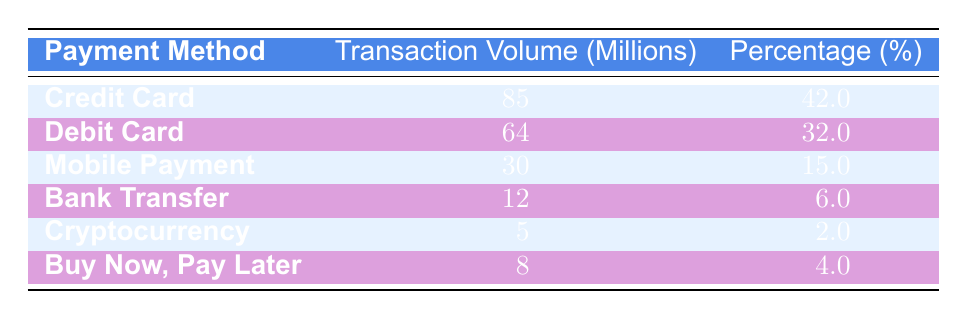What is the transaction volume for Credit Card payments? The table shows that the transaction volume for Credit Card payments is listed as 85 million.
Answer: 85 million What percentage of the total transaction volume comes from Debit Card payments? According to the table, the percentage of the total transaction volume for Debit Card payments is 32%.
Answer: 32% Which payment method has the lowest transaction volume, and what is that volume? The payment method with the lowest transaction volume listed in the table is Cryptocurrency, with a volume of 5 million.
Answer: Cryptocurrency, 5 million What is the total transaction volume for Mobile Payment and Buy Now, Pay Later combined? From the table, Mobile Payment has a volume of 30 million and Buy Now, Pay Later has a volume of 8 million. The total is 30 + 8 = 38 million.
Answer: 38 million Is the transaction volume from Bank Transfer greater than that from Cryptocurrency? The table shows that Bank Transfer has a transaction volume of 12 million, while Cryptocurrency has 5 million. Since 12 million is greater than 5 million, the statement is true.
Answer: Yes What percentage of the total transaction volume is accounted for by Mobile Payment and Cryptocurrency together? The table shows that Mobile Payment accounts for 15% and Cryptocurrency for 2%. Adding these percentages gives 15 + 2 = 17%.
Answer: 17% Which payment method contributes 6% to the total transaction volume? The table indicates that Bank Transfer has a contribution of 6% to the total transaction volume.
Answer: Bank Transfer What is the average transaction volume of the top three payment methods? The top three payment methods in the table by transaction volume are Credit Card (85 million), Debit Card (64 million), and Mobile Payment (30 million). The total volume for these three is 85 + 64 + 30 = 179 million. Dividing by 3 gives an average of 179 / 3 = 59.67 million.
Answer: 59.67 million 